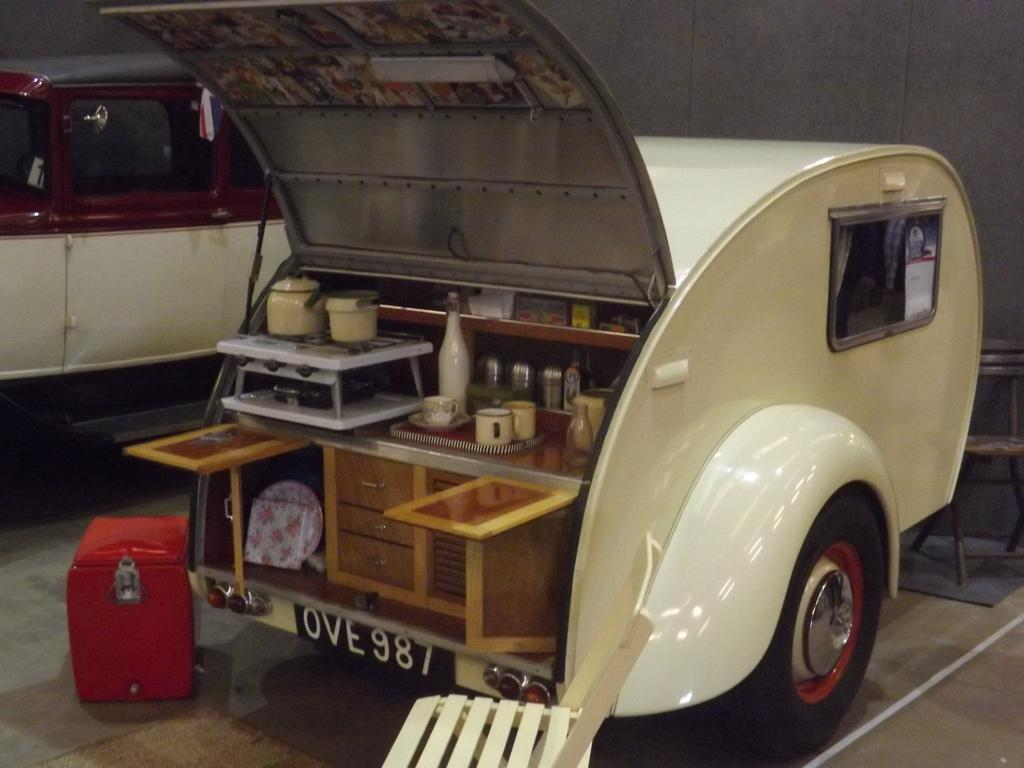What objects can be seen in the foreground of the image? There are cups, wooden cupboards, and a bottle in the foreground of the image. What type of vehicle are the items located in? The items are in a vehicle. Can you describe any other objects in the foreground of the image? There are other items in the foreground of the image. What is the color of the box on the floor? The box on the floor is red. Is there another vehicle visible in the image? Yes, there is another vehicle on the left side of the image. What type of sticks are used to stir the cups in the image? There are no sticks visible in the image; only cups, wooden cupboards, a bottle, and other items are present. 